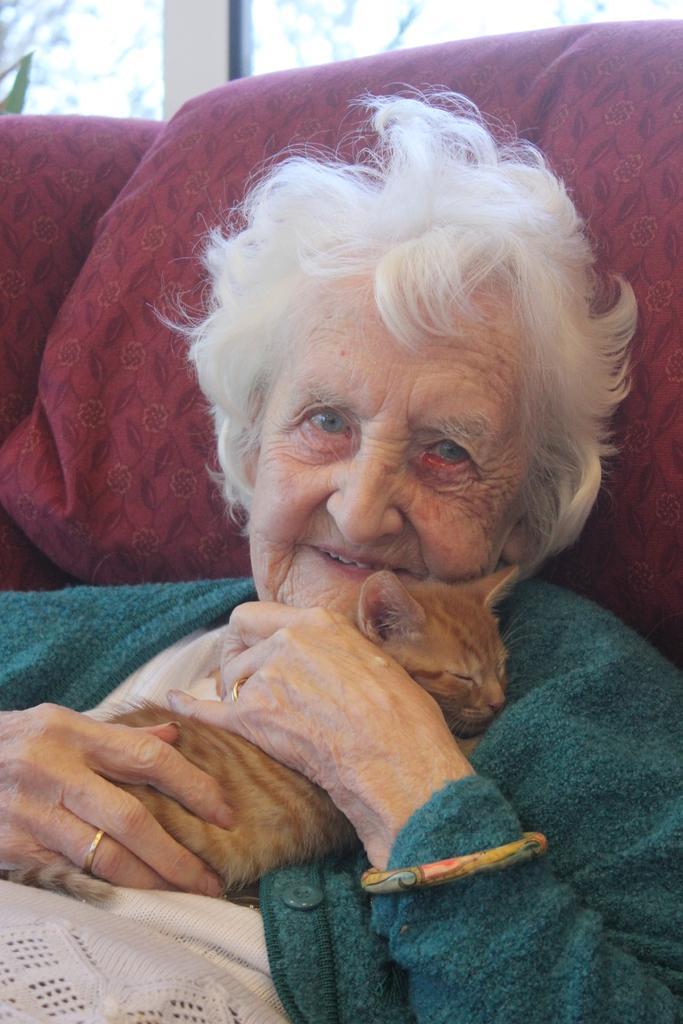Describe this image in one or two sentences. In this image i can see a old lady holding a cat. 